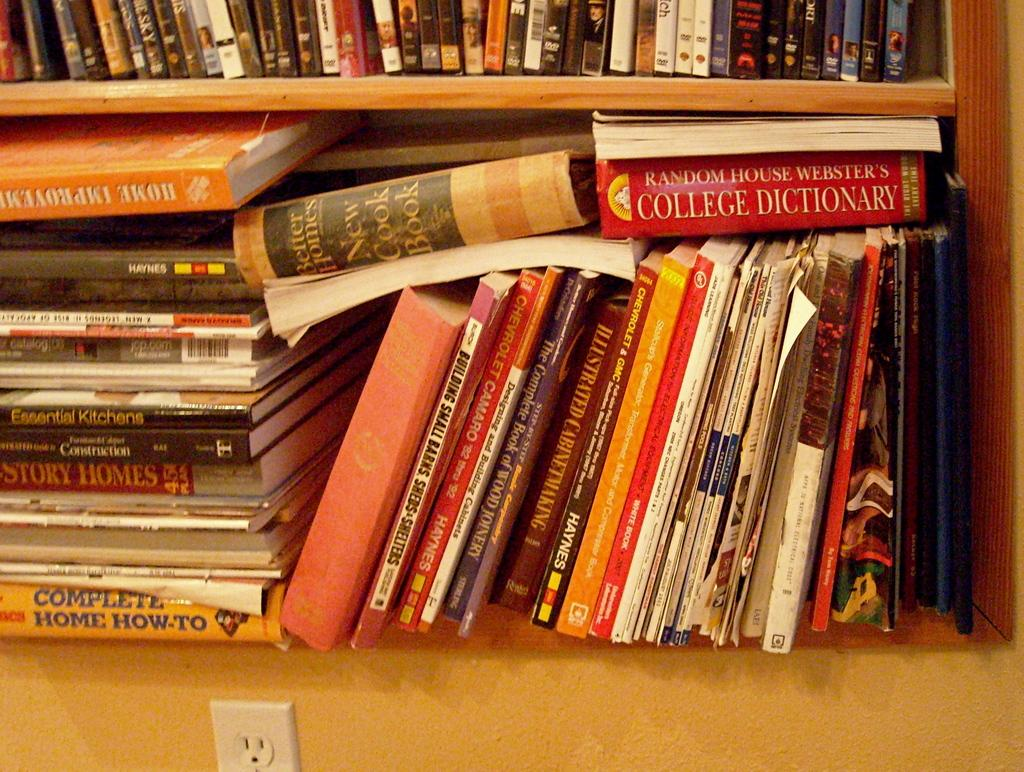<image>
Offer a succinct explanation of the picture presented. A collection of books, including a cook book and a dictionary. 